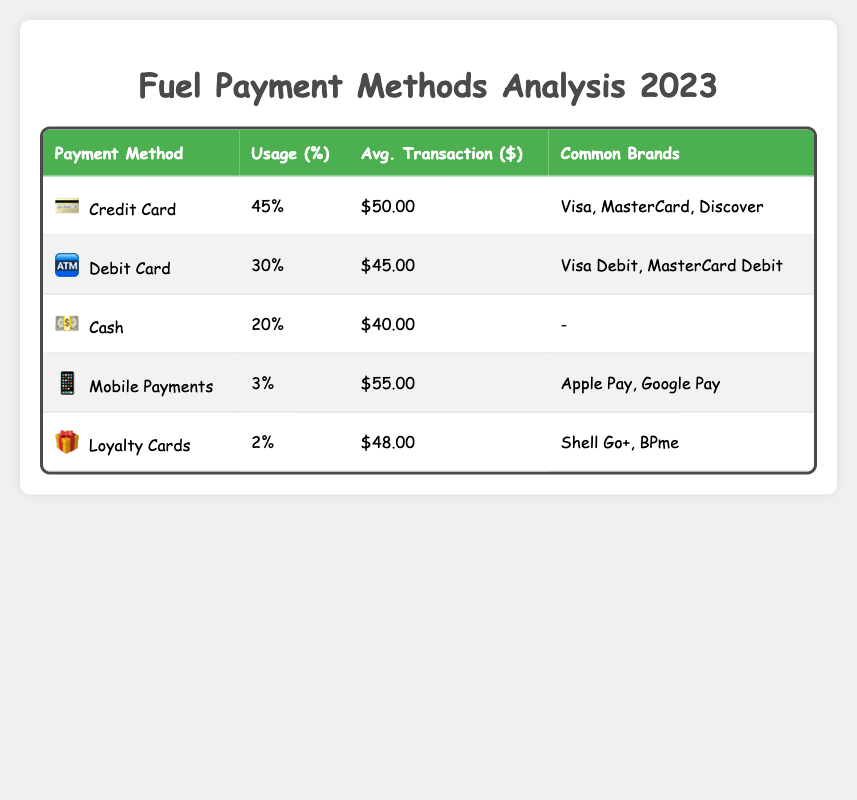What is the payment method used by the highest percentage of customers? The table shows the percentages of various payment methods used by customers. The method with the highest percentage is "Credit Card" at 45%.
Answer: Credit Card Which payment method has the lowest usage percentage? The table lists all the payment methods and their corresponding usage percentages. "Loyalty Cards" have the lowest percentage of usage at 2%.
Answer: Loyalty Cards What is the average transaction value for cash payments? Referring to the table, the row for "Cash" shows an average transaction value of $40.00.
Answer: $40.00 How much more do customers spend on average when using mobile payments compared to cash? The average transaction value for mobile payments is $55.00, while for cash it is $40.00. To find the difference, subtract the cash average from the mobile average: 55 - 40 = 15.
Answer: $15.00 Is the average transaction value for debit cards greater than that for credit cards? The average transaction value for debit cards is $45.00, while for credit cards it is $50.00. Since $45.00 is less than $50.00, the statement is false.
Answer: No What is the combined percentage of cash and mobile payment users? The table shows that the percentage of cash users is 20% and mobile payment users is 3%. Adding both together gives: 20 + 3 = 23%.
Answer: 23% Among the payment methods listed, do any have common brands? The table provides information on common brands for each payment method. "Cash" does not have common brands, while others like "Credit Card" and "Mobile Payments" do. Therefore, the answer is yes.
Answer: Yes If a customer pays with a loyalty card, what would their average transaction value be? The average transaction value for loyalty cards, as shown in the table, is $48.00.
Answer: $48.00 What percentage of customers prefer debit cards over mobile payments? The table indicates that 30% of customers use debit cards, while only 3% use mobile payments. To find the difference: 30 - 3 = 27%.
Answer: 27% 